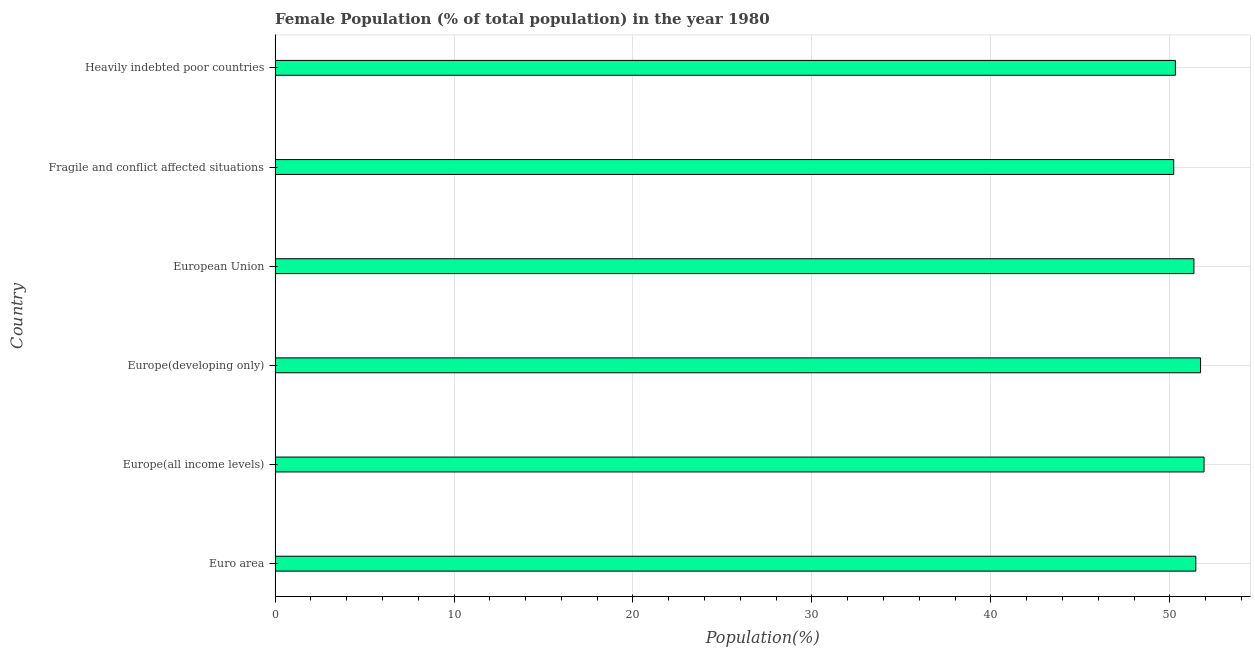Does the graph contain any zero values?
Provide a short and direct response. No. What is the title of the graph?
Your response must be concise. Female Population (% of total population) in the year 1980. What is the label or title of the X-axis?
Provide a succinct answer. Population(%). What is the label or title of the Y-axis?
Make the answer very short. Country. What is the female population in Euro area?
Give a very brief answer. 51.45. Across all countries, what is the maximum female population?
Your answer should be compact. 51.91. Across all countries, what is the minimum female population?
Provide a short and direct response. 50.22. In which country was the female population maximum?
Ensure brevity in your answer.  Europe(all income levels). In which country was the female population minimum?
Offer a very short reply. Fragile and conflict affected situations. What is the sum of the female population?
Your response must be concise. 306.95. What is the difference between the female population in European Union and Heavily indebted poor countries?
Offer a very short reply. 1.04. What is the average female population per country?
Provide a succinct answer. 51.16. What is the median female population?
Offer a very short reply. 51.4. In how many countries, is the female population greater than 4 %?
Provide a short and direct response. 6. What is the ratio of the female population in Euro area to that in European Union?
Provide a short and direct response. 1. Is the female population in Europe(all income levels) less than that in European Union?
Ensure brevity in your answer.  No. What is the difference between the highest and the second highest female population?
Offer a terse response. 0.19. Is the sum of the female population in Euro area and Europe(developing only) greater than the maximum female population across all countries?
Your answer should be very brief. Yes. What is the difference between the highest and the lowest female population?
Offer a terse response. 1.69. In how many countries, is the female population greater than the average female population taken over all countries?
Make the answer very short. 4. How many bars are there?
Your answer should be very brief. 6. What is the Population(%) of Euro area?
Keep it short and to the point. 51.45. What is the Population(%) in Europe(all income levels)?
Your answer should be very brief. 51.91. What is the Population(%) of Europe(developing only)?
Provide a succinct answer. 51.72. What is the Population(%) of European Union?
Provide a succinct answer. 51.34. What is the Population(%) in Fragile and conflict affected situations?
Ensure brevity in your answer.  50.22. What is the Population(%) in Heavily indebted poor countries?
Keep it short and to the point. 50.31. What is the difference between the Population(%) in Euro area and Europe(all income levels)?
Your answer should be very brief. -0.46. What is the difference between the Population(%) in Euro area and Europe(developing only)?
Your response must be concise. -0.27. What is the difference between the Population(%) in Euro area and European Union?
Provide a short and direct response. 0.11. What is the difference between the Population(%) in Euro area and Fragile and conflict affected situations?
Your answer should be compact. 1.24. What is the difference between the Population(%) in Euro area and Heavily indebted poor countries?
Provide a short and direct response. 1.14. What is the difference between the Population(%) in Europe(all income levels) and Europe(developing only)?
Offer a terse response. 0.19. What is the difference between the Population(%) in Europe(all income levels) and European Union?
Your answer should be compact. 0.57. What is the difference between the Population(%) in Europe(all income levels) and Fragile and conflict affected situations?
Give a very brief answer. 1.69. What is the difference between the Population(%) in Europe(all income levels) and Heavily indebted poor countries?
Your answer should be compact. 1.6. What is the difference between the Population(%) in Europe(developing only) and European Union?
Offer a terse response. 0.37. What is the difference between the Population(%) in Europe(developing only) and Fragile and conflict affected situations?
Ensure brevity in your answer.  1.5. What is the difference between the Population(%) in Europe(developing only) and Heavily indebted poor countries?
Keep it short and to the point. 1.41. What is the difference between the Population(%) in European Union and Fragile and conflict affected situations?
Offer a terse response. 1.13. What is the difference between the Population(%) in European Union and Heavily indebted poor countries?
Offer a very short reply. 1.04. What is the difference between the Population(%) in Fragile and conflict affected situations and Heavily indebted poor countries?
Your answer should be very brief. -0.09. What is the ratio of the Population(%) in Euro area to that in Europe(all income levels)?
Your answer should be very brief. 0.99. What is the ratio of the Population(%) in Euro area to that in Heavily indebted poor countries?
Offer a terse response. 1.02. What is the ratio of the Population(%) in Europe(all income levels) to that in Fragile and conflict affected situations?
Offer a very short reply. 1.03. What is the ratio of the Population(%) in Europe(all income levels) to that in Heavily indebted poor countries?
Offer a very short reply. 1.03. What is the ratio of the Population(%) in Europe(developing only) to that in European Union?
Offer a terse response. 1.01. What is the ratio of the Population(%) in Europe(developing only) to that in Heavily indebted poor countries?
Your response must be concise. 1.03. What is the ratio of the Population(%) in European Union to that in Fragile and conflict affected situations?
Your answer should be very brief. 1.02. What is the ratio of the Population(%) in European Union to that in Heavily indebted poor countries?
Ensure brevity in your answer.  1.02. What is the ratio of the Population(%) in Fragile and conflict affected situations to that in Heavily indebted poor countries?
Your response must be concise. 1. 